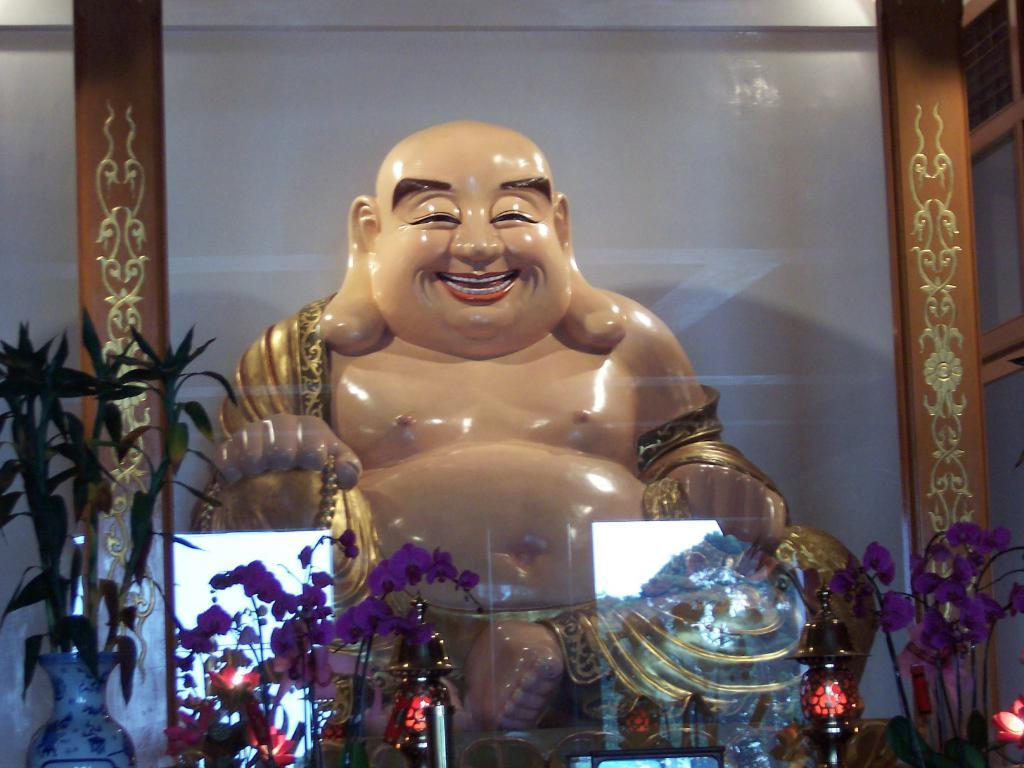What is inside the transparent glass in the image? There is a statue in a transparent glass in the image. What type of decorative items can be seen in the image? There are artificial flowers and artificial plants in the image. How many objects can be identified in the image? There are a few objects visible in the image. What is the manager doing in the image? There is no manager present in the image. How many pots are visible in the image? There is no pot present in the image. 